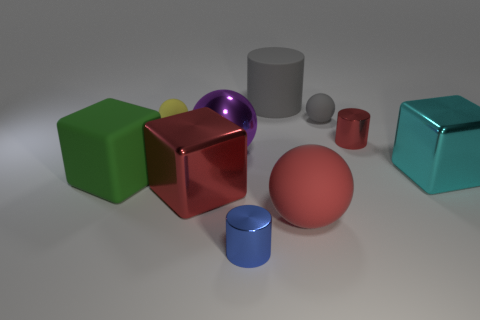Subtract all cylinders. How many objects are left? 7 Subtract 1 red balls. How many objects are left? 9 Subtract all tiny gray balls. Subtract all big gray matte cylinders. How many objects are left? 8 Add 5 yellow balls. How many yellow balls are left? 6 Add 7 tiny metal objects. How many tiny metal objects exist? 9 